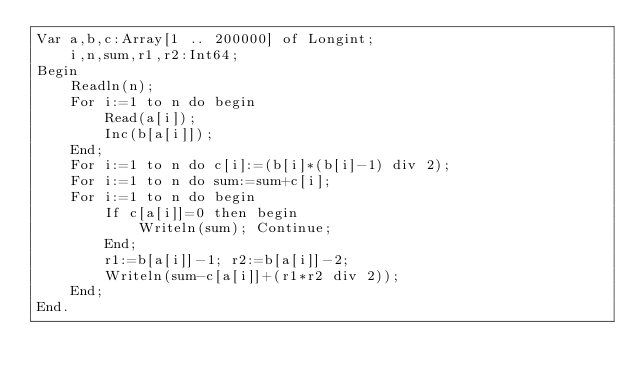Convert code to text. <code><loc_0><loc_0><loc_500><loc_500><_Pascal_>Var a,b,c:Array[1 .. 200000] of Longint;
    i,n,sum,r1,r2:Int64;
Begin
    Readln(n);
    For i:=1 to n do begin
        Read(a[i]);
        Inc(b[a[i]]);
    End;
    For i:=1 to n do c[i]:=(b[i]*(b[i]-1) div 2);
    For i:=1 to n do sum:=sum+c[i];
    For i:=1 to n do begin
        If c[a[i]]=0 then begin
            Writeln(sum); Continue;
        End;
        r1:=b[a[i]]-1; r2:=b[a[i]]-2;
        Writeln(sum-c[a[i]]+(r1*r2 div 2));
    End;
End.</code> 